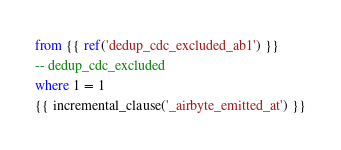<code> <loc_0><loc_0><loc_500><loc_500><_SQL_>from {{ ref('dedup_cdc_excluded_ab1') }}
-- dedup_cdc_excluded
where 1 = 1
{{ incremental_clause('_airbyte_emitted_at') }}

</code> 